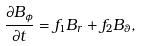Convert formula to latex. <formula><loc_0><loc_0><loc_500><loc_500>\frac { \partial B _ { \phi } } { \partial t } = f _ { 1 } B _ { r } + f _ { 2 } B _ { \theta } ,</formula> 